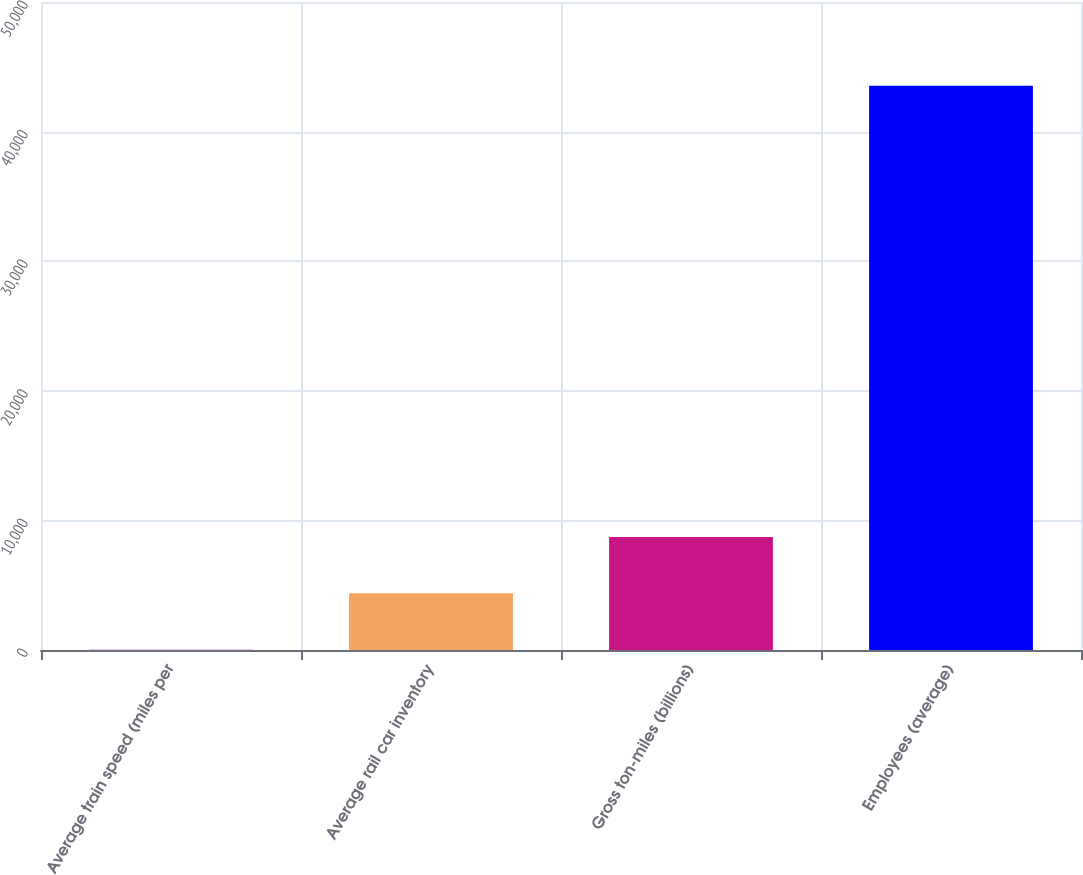Convert chart. <chart><loc_0><loc_0><loc_500><loc_500><bar_chart><fcel>Average train speed (miles per<fcel>Average rail car inventory<fcel>Gross ton-miles (billions)<fcel>Employees (average)<nl><fcel>27.3<fcel>4377.67<fcel>8728.04<fcel>43531<nl></chart> 